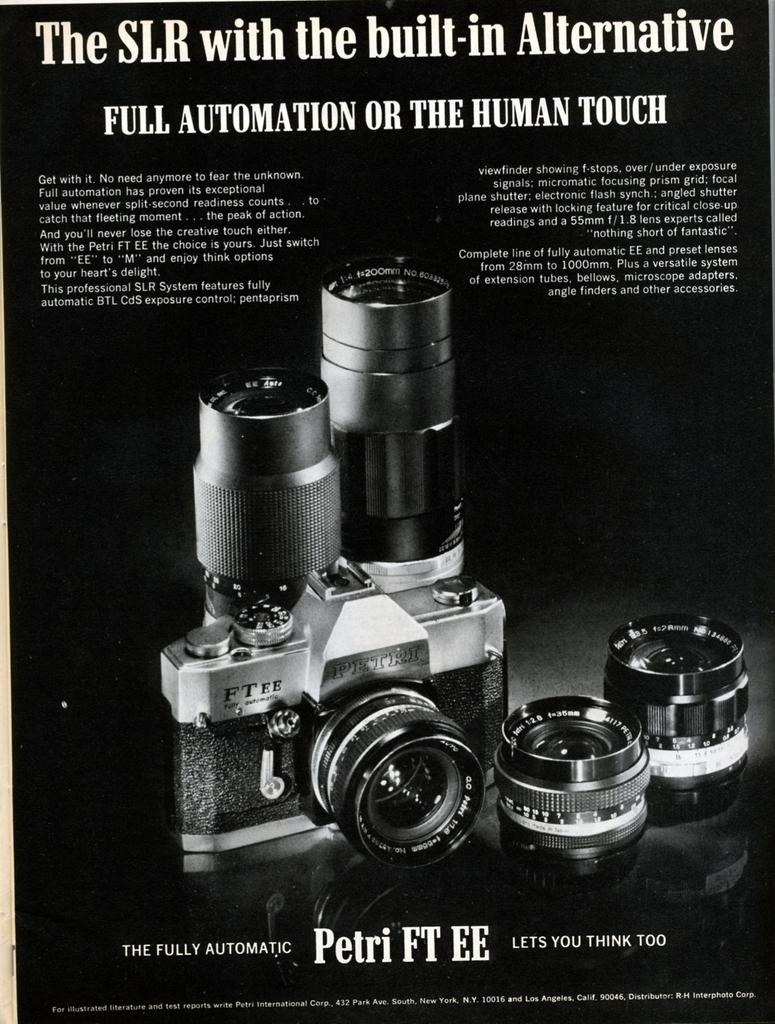What is the main subject of the image? The main subject of the image is a camera. What specific feature can be seen on the camera? There are multiple lenses visible on the camera. Is there any text present on the camera? Yes, there is text present on the camera. How many lizards can be seen crawling on the camera in the image? There are no lizards present in the image; it features a camera with multiple lenses and text. What type of lamp is used to illuminate the camera in the image? There is no lamp present in the image; it only shows the camera with its features. 